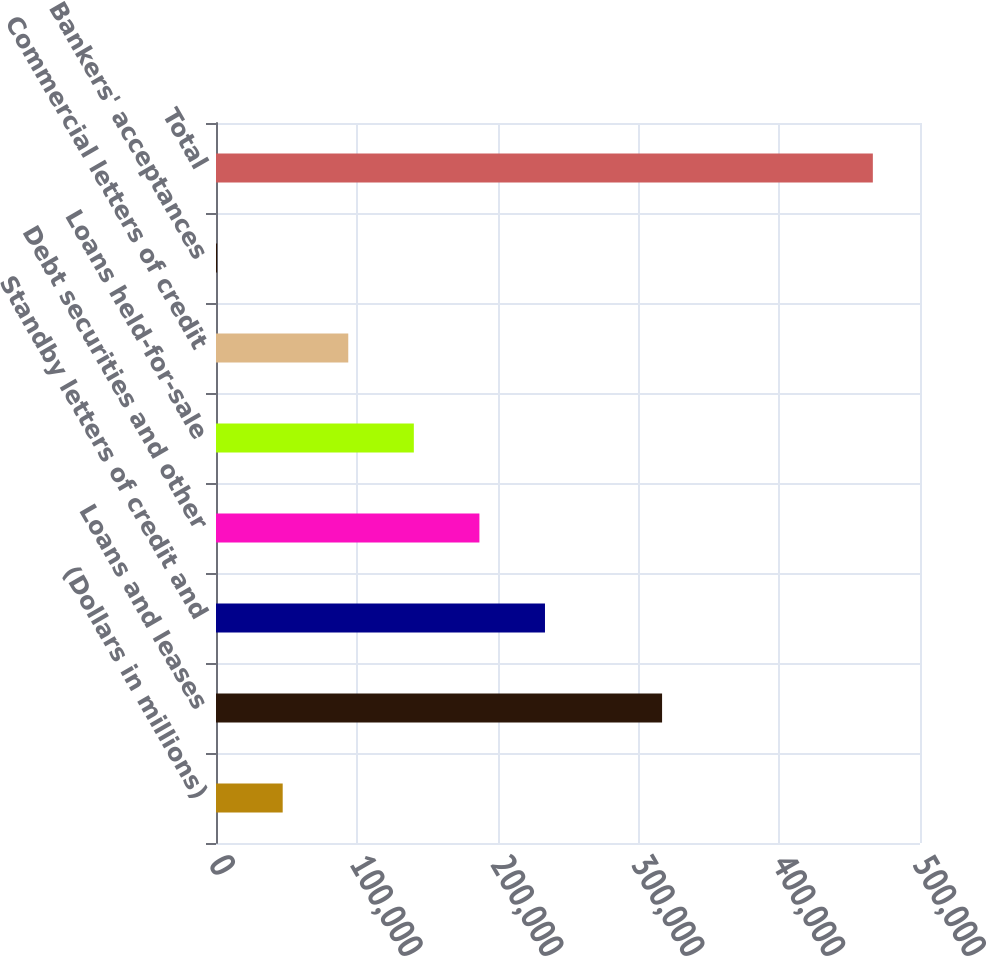Convert chart. <chart><loc_0><loc_0><loc_500><loc_500><bar_chart><fcel>(Dollars in millions)<fcel>Loans and leases<fcel>Standby letters of credit and<fcel>Debt securities and other<fcel>Loans held-for-sale<fcel>Commercial letters of credit<fcel>Bankers' acceptances<fcel>Total<nl><fcel>47368.2<fcel>316816<fcel>233653<fcel>187082<fcel>140511<fcel>93939.4<fcel>797<fcel>466509<nl></chart> 